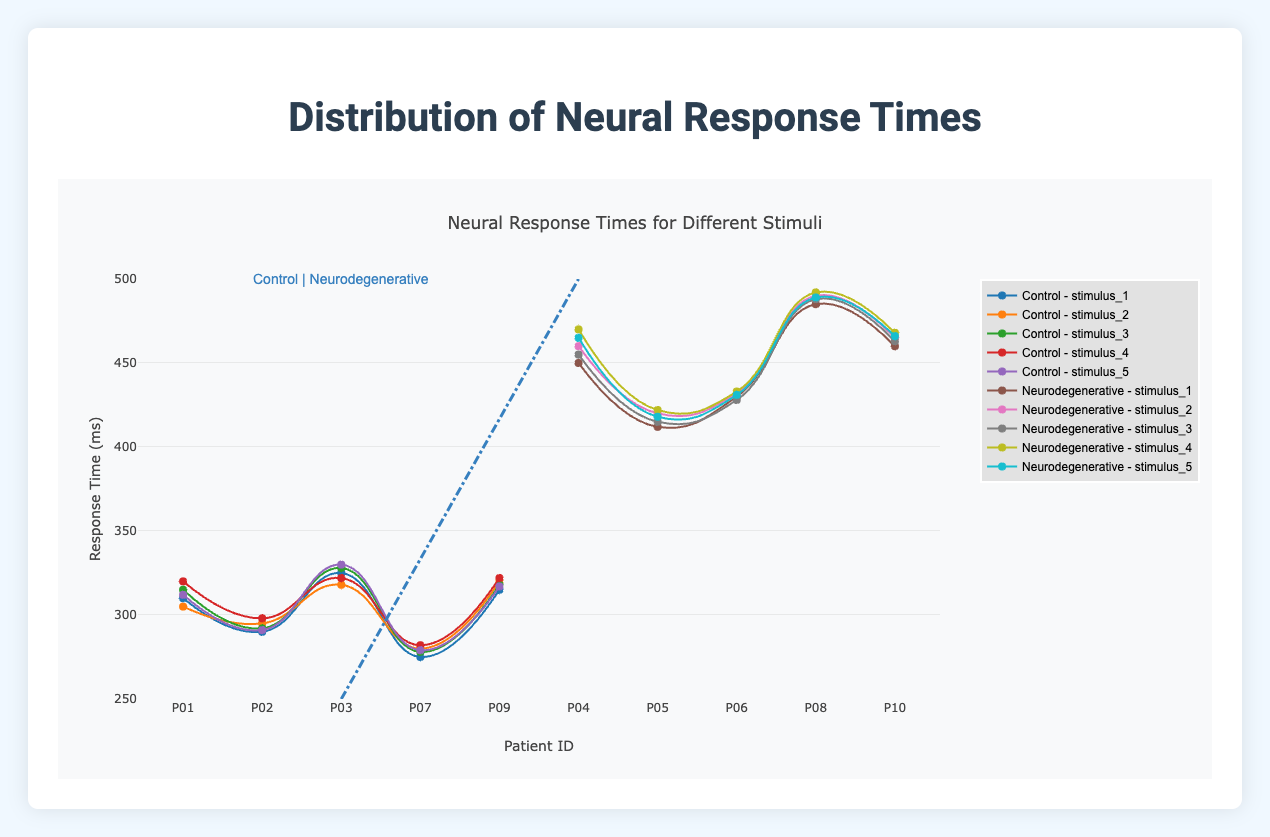Which group shows generally higher neural response times across all stimuli? By comparing the average heights of the curves, it is clear that the neurodegenerative group shows higher response times for all stimuli compared to the control group.
Answer: Neurodegenerative In the control group, which stimulus has the highest response times on average? To find this, we calculate the average response time for each stimulus in the control group and compare them. (St1: 310+290+325+275+315)/5, (St2: 305+295+318+280+320)/5, (St3: 315+292+328+278+318)/5, (St4: 320+298+322+282+322)/5, (St5: 312+291+330+279+317)/5. We then identify the highest average value.
Answer: Stimulus 3 How does the response time for patient P04 to stimulus 3 compare to the response time for patient P01 to stimulus 3? Patient P04 (neurodegenerative) has a response time of 455 ms for stimulus 3, while patient P01 (control) has a response time of 315 ms.
Answer: P04's response time is higher Between patients P02 and P09, who has a lower response time for stimulus 4? For stimulus 4, patient P02 has a response time of 298 ms and patient P09 has a response time of 322 ms. Comparing these values, patient P02 has a lower response time.
Answer: P02 Which stimulus shows the maximum response time for patient P10? Patient P10's response times for the stimuli are: St1: 460, St2: 465, St3: 463, St4: 468, St5: 466. The maximum value among these is for stimulus 4.
Answer: Stimulus 4 What is the range of response times for patient P03 across all stimuli? For patient P03, the response times are St1: 325, St2: 318, St3: 328, St4: 322, St5: 330. The range is the difference between the maximum and minimum values. Range = 330 - 318.
Answer: 12 ms What is the overall trend observed in the neural response times from control to neurodegenerative groups? Observing the plotted traces, the neural response times generally increase from the control to the neurodegenerative group for all stimuli, indicating slower response in patients with neurodegenerative conditions.
Answer: Increase Compare the response times of neurodegenerative patients for stimulus 2 (P04, P05, P06, P08, P10). Who has the least response time? For stimulus 2, response times are: P04: 460, P05: 420, P06: 432, P08: 490, P10: 465. The least response time among these is P05 with 420 ms.
Answer: P05 